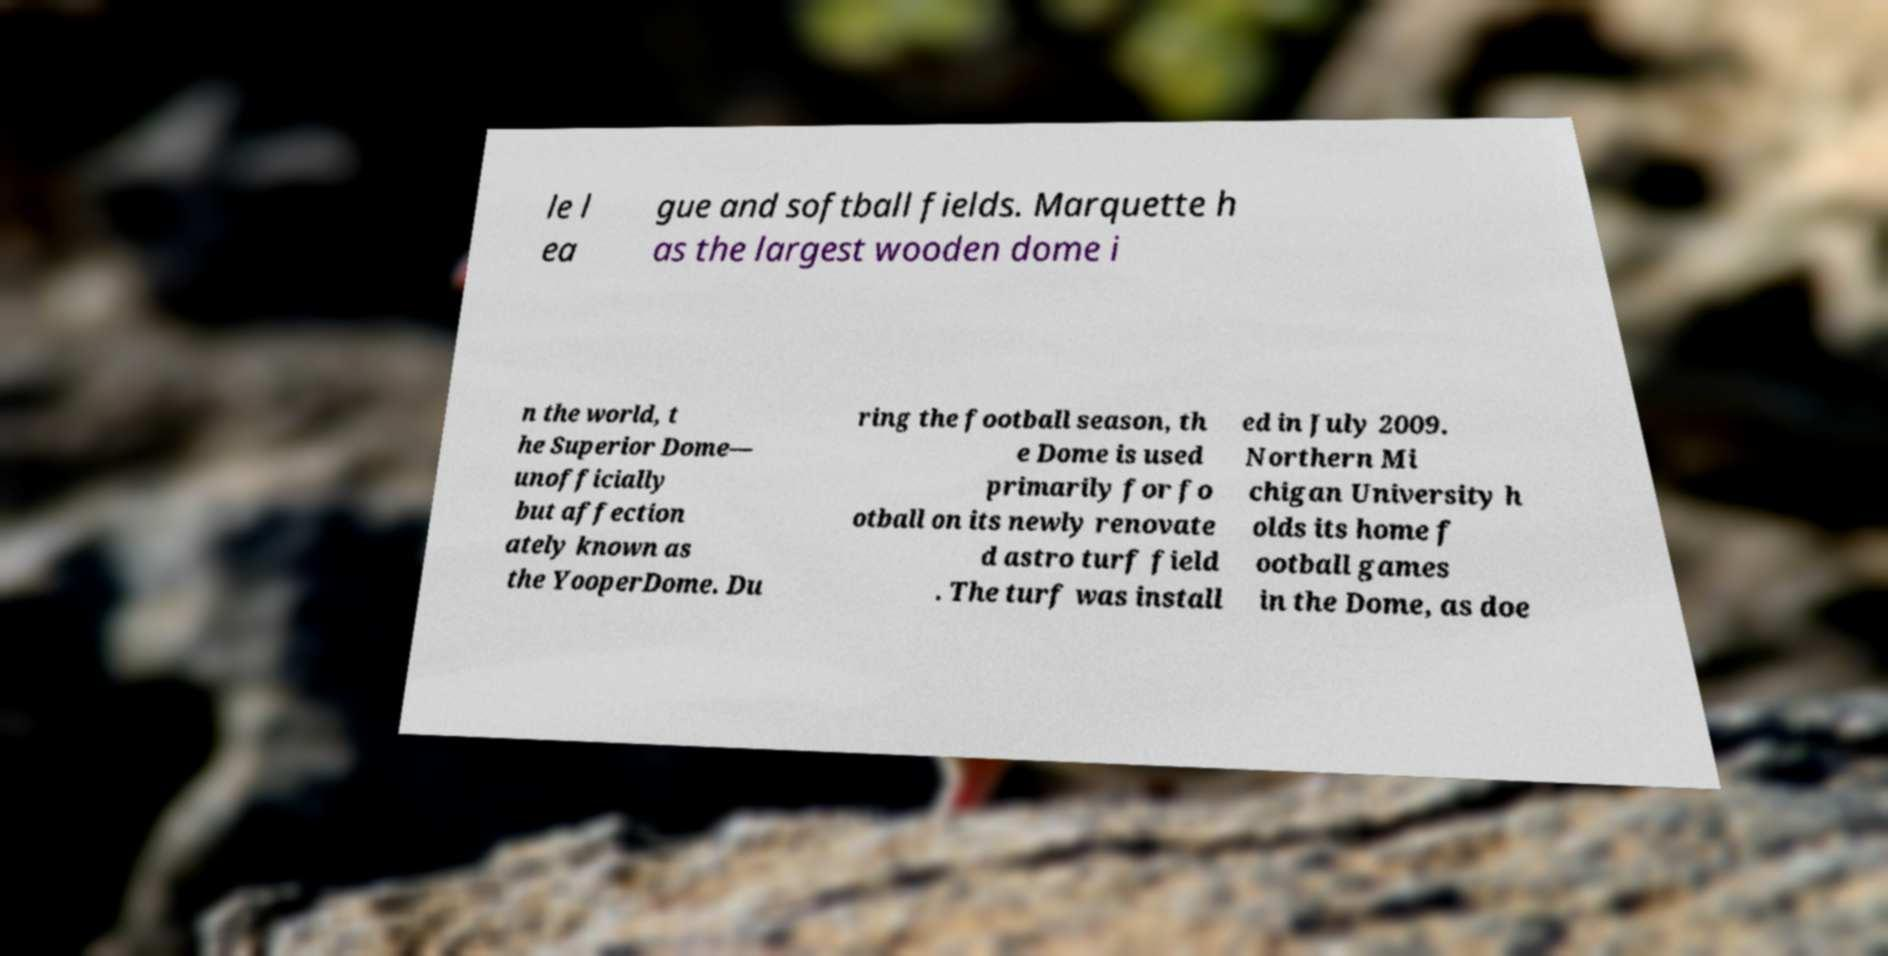Please read and relay the text visible in this image. What does it say? le l ea gue and softball fields. Marquette h as the largest wooden dome i n the world, t he Superior Dome— unofficially but affection ately known as the YooperDome. Du ring the football season, th e Dome is used primarily for fo otball on its newly renovate d astro turf field . The turf was install ed in July 2009. Northern Mi chigan University h olds its home f ootball games in the Dome, as doe 